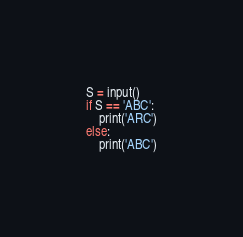Convert code to text. <code><loc_0><loc_0><loc_500><loc_500><_Python_>S = input()
if S == 'ABC':
    print('ARC')
else:
    print('ABC')</code> 